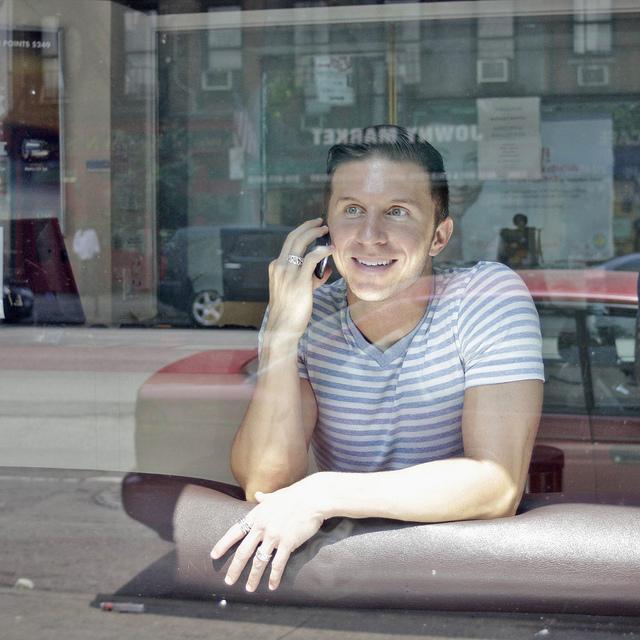What is outside the window?
Write a very short answer. Car. What style of neck is his shirt?
Concise answer only. V neck. How many rings is the man wearing?
Concise answer only. 3. 